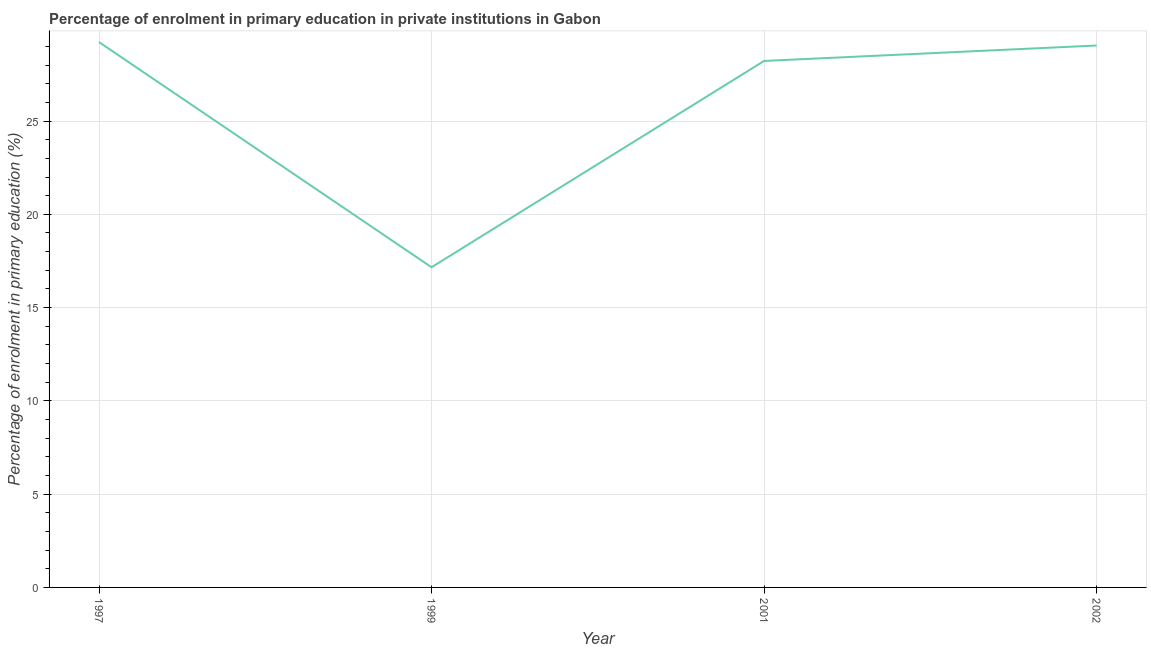What is the enrolment percentage in primary education in 1997?
Your response must be concise. 29.23. Across all years, what is the maximum enrolment percentage in primary education?
Offer a terse response. 29.23. Across all years, what is the minimum enrolment percentage in primary education?
Provide a short and direct response. 17.16. In which year was the enrolment percentage in primary education maximum?
Offer a terse response. 1997. In which year was the enrolment percentage in primary education minimum?
Provide a short and direct response. 1999. What is the sum of the enrolment percentage in primary education?
Provide a succinct answer. 103.66. What is the difference between the enrolment percentage in primary education in 1997 and 2002?
Your answer should be compact. 0.18. What is the average enrolment percentage in primary education per year?
Ensure brevity in your answer.  25.92. What is the median enrolment percentage in primary education?
Your answer should be very brief. 28.63. In how many years, is the enrolment percentage in primary education greater than 26 %?
Make the answer very short. 3. Do a majority of the years between 1997 and 2002 (inclusive) have enrolment percentage in primary education greater than 23 %?
Provide a short and direct response. Yes. What is the ratio of the enrolment percentage in primary education in 1997 to that in 2001?
Give a very brief answer. 1.04. Is the difference between the enrolment percentage in primary education in 1999 and 2001 greater than the difference between any two years?
Your answer should be compact. No. What is the difference between the highest and the second highest enrolment percentage in primary education?
Offer a very short reply. 0.18. What is the difference between the highest and the lowest enrolment percentage in primary education?
Make the answer very short. 12.07. In how many years, is the enrolment percentage in primary education greater than the average enrolment percentage in primary education taken over all years?
Your answer should be compact. 3. How many lines are there?
Offer a terse response. 1. How many years are there in the graph?
Offer a terse response. 4. Does the graph contain any zero values?
Keep it short and to the point. No. What is the title of the graph?
Keep it short and to the point. Percentage of enrolment in primary education in private institutions in Gabon. What is the label or title of the Y-axis?
Ensure brevity in your answer.  Percentage of enrolment in primary education (%). What is the Percentage of enrolment in primary education (%) of 1997?
Your answer should be very brief. 29.23. What is the Percentage of enrolment in primary education (%) in 1999?
Offer a very short reply. 17.16. What is the Percentage of enrolment in primary education (%) in 2001?
Give a very brief answer. 28.22. What is the Percentage of enrolment in primary education (%) of 2002?
Your answer should be compact. 29.05. What is the difference between the Percentage of enrolment in primary education (%) in 1997 and 1999?
Your response must be concise. 12.07. What is the difference between the Percentage of enrolment in primary education (%) in 1997 and 2001?
Ensure brevity in your answer.  1.01. What is the difference between the Percentage of enrolment in primary education (%) in 1997 and 2002?
Offer a very short reply. 0.18. What is the difference between the Percentage of enrolment in primary education (%) in 1999 and 2001?
Offer a very short reply. -11.06. What is the difference between the Percentage of enrolment in primary education (%) in 1999 and 2002?
Give a very brief answer. -11.89. What is the difference between the Percentage of enrolment in primary education (%) in 2001 and 2002?
Offer a very short reply. -0.83. What is the ratio of the Percentage of enrolment in primary education (%) in 1997 to that in 1999?
Offer a very short reply. 1.7. What is the ratio of the Percentage of enrolment in primary education (%) in 1997 to that in 2001?
Your response must be concise. 1.04. What is the ratio of the Percentage of enrolment in primary education (%) in 1999 to that in 2001?
Keep it short and to the point. 0.61. What is the ratio of the Percentage of enrolment in primary education (%) in 1999 to that in 2002?
Make the answer very short. 0.59. What is the ratio of the Percentage of enrolment in primary education (%) in 2001 to that in 2002?
Give a very brief answer. 0.97. 